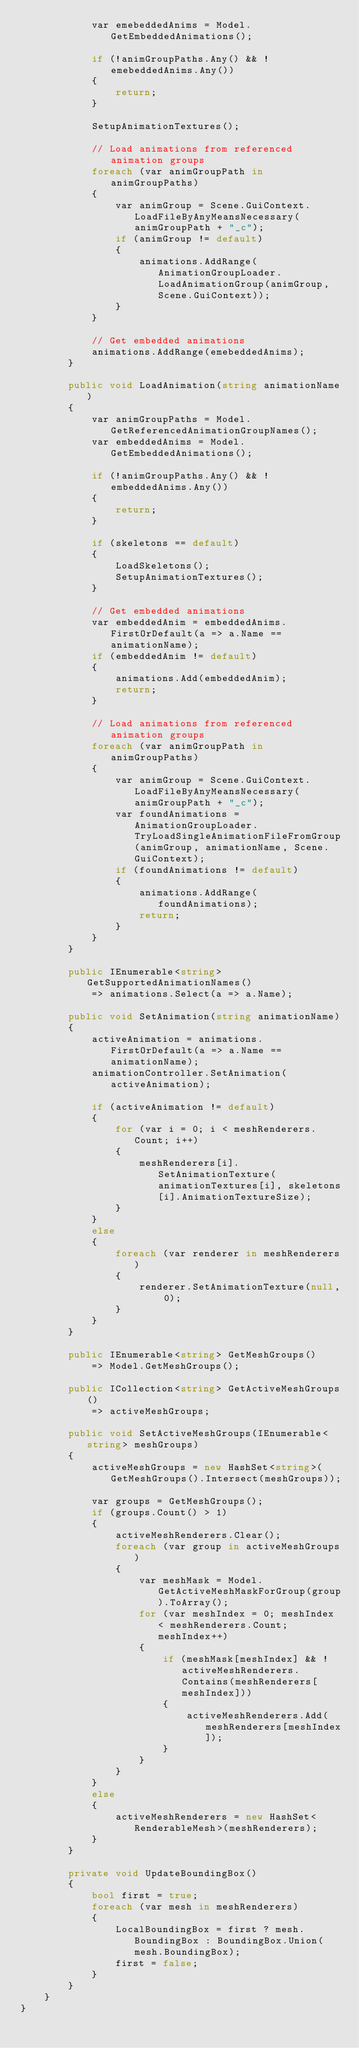<code> <loc_0><loc_0><loc_500><loc_500><_C#_>            var emebeddedAnims = Model.GetEmbeddedAnimations();

            if (!animGroupPaths.Any() && !emebeddedAnims.Any())
            {
                return;
            }

            SetupAnimationTextures();

            // Load animations from referenced animation groups
            foreach (var animGroupPath in animGroupPaths)
            {
                var animGroup = Scene.GuiContext.LoadFileByAnyMeansNecessary(animGroupPath + "_c");
                if (animGroup != default)
                {
                    animations.AddRange(AnimationGroupLoader.LoadAnimationGroup(animGroup, Scene.GuiContext));
                }
            }

            // Get embedded animations
            animations.AddRange(emebeddedAnims);
        }

        public void LoadAnimation(string animationName)
        {
            var animGroupPaths = Model.GetReferencedAnimationGroupNames();
            var embeddedAnims = Model.GetEmbeddedAnimations();

            if (!animGroupPaths.Any() && !embeddedAnims.Any())
            {
                return;
            }

            if (skeletons == default)
            {
                LoadSkeletons();
                SetupAnimationTextures();
            }

            // Get embedded animations
            var embeddedAnim = embeddedAnims.FirstOrDefault(a => a.Name == animationName);
            if (embeddedAnim != default)
            {
                animations.Add(embeddedAnim);
                return;
            }

            // Load animations from referenced animation groups
            foreach (var animGroupPath in animGroupPaths)
            {
                var animGroup = Scene.GuiContext.LoadFileByAnyMeansNecessary(animGroupPath + "_c");
                var foundAnimations = AnimationGroupLoader.TryLoadSingleAnimationFileFromGroup(animGroup, animationName, Scene.GuiContext);
                if (foundAnimations != default)
                {
                    animations.AddRange(foundAnimations);
                    return;
                }
            }
        }

        public IEnumerable<string> GetSupportedAnimationNames()
            => animations.Select(a => a.Name);

        public void SetAnimation(string animationName)
        {
            activeAnimation = animations.FirstOrDefault(a => a.Name == animationName);
            animationController.SetAnimation(activeAnimation);

            if (activeAnimation != default)
            {
                for (var i = 0; i < meshRenderers.Count; i++)
                {
                    meshRenderers[i].SetAnimationTexture(animationTextures[i], skeletons[i].AnimationTextureSize);
                }
            }
            else
            {
                foreach (var renderer in meshRenderers)
                {
                    renderer.SetAnimationTexture(null, 0);
                }
            }
        }

        public IEnumerable<string> GetMeshGroups()
            => Model.GetMeshGroups();

        public ICollection<string> GetActiveMeshGroups()
            => activeMeshGroups;

        public void SetActiveMeshGroups(IEnumerable<string> meshGroups)
        {
            activeMeshGroups = new HashSet<string>(GetMeshGroups().Intersect(meshGroups));

            var groups = GetMeshGroups();
            if (groups.Count() > 1)
            {
                activeMeshRenderers.Clear();
                foreach (var group in activeMeshGroups)
                {
                    var meshMask = Model.GetActiveMeshMaskForGroup(group).ToArray();
                    for (var meshIndex = 0; meshIndex < meshRenderers.Count; meshIndex++)
                    {
                        if (meshMask[meshIndex] && !activeMeshRenderers.Contains(meshRenderers[meshIndex]))
                        {
                            activeMeshRenderers.Add(meshRenderers[meshIndex]);
                        }
                    }
                }
            }
            else
            {
                activeMeshRenderers = new HashSet<RenderableMesh>(meshRenderers);
            }
        }

        private void UpdateBoundingBox()
        {
            bool first = true;
            foreach (var mesh in meshRenderers)
            {
                LocalBoundingBox = first ? mesh.BoundingBox : BoundingBox.Union(mesh.BoundingBox);
                first = false;
            }
        }
    }
}
</code> 